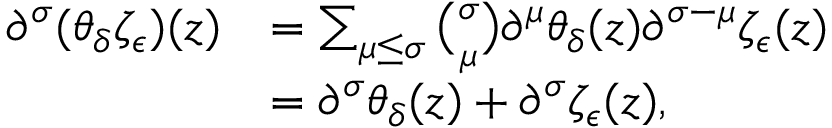<formula> <loc_0><loc_0><loc_500><loc_500>\begin{array} { r l } { \partial ^ { \sigma } ( \theta _ { \delta } \zeta _ { \epsilon } ) ( z ) } & { = \sum _ { \mu \leq \sigma } { \binom { \sigma } { \mu } } \partial ^ { \mu } \theta _ { \delta } ( z ) \partial ^ { \sigma - \mu } \zeta _ { \epsilon } ( z ) } \\ & { = \partial ^ { \sigma } \theta _ { \delta } ( z ) + \partial ^ { \sigma } \zeta _ { \epsilon } ( z ) , } \end{array}</formula> 